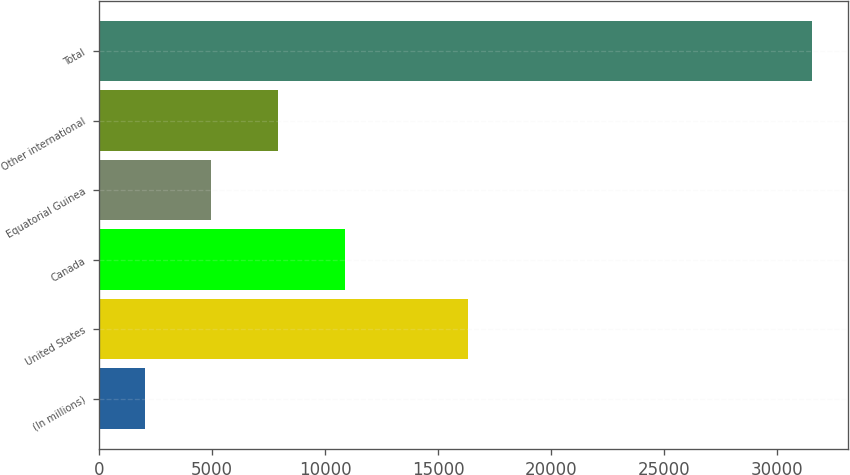Convert chart. <chart><loc_0><loc_0><loc_500><loc_500><bar_chart><fcel>(In millions)<fcel>United States<fcel>Canada<fcel>Equatorial Guinea<fcel>Other international<fcel>Total<nl><fcel>2008<fcel>16298<fcel>10862.8<fcel>4959.6<fcel>7911.2<fcel>31524<nl></chart> 